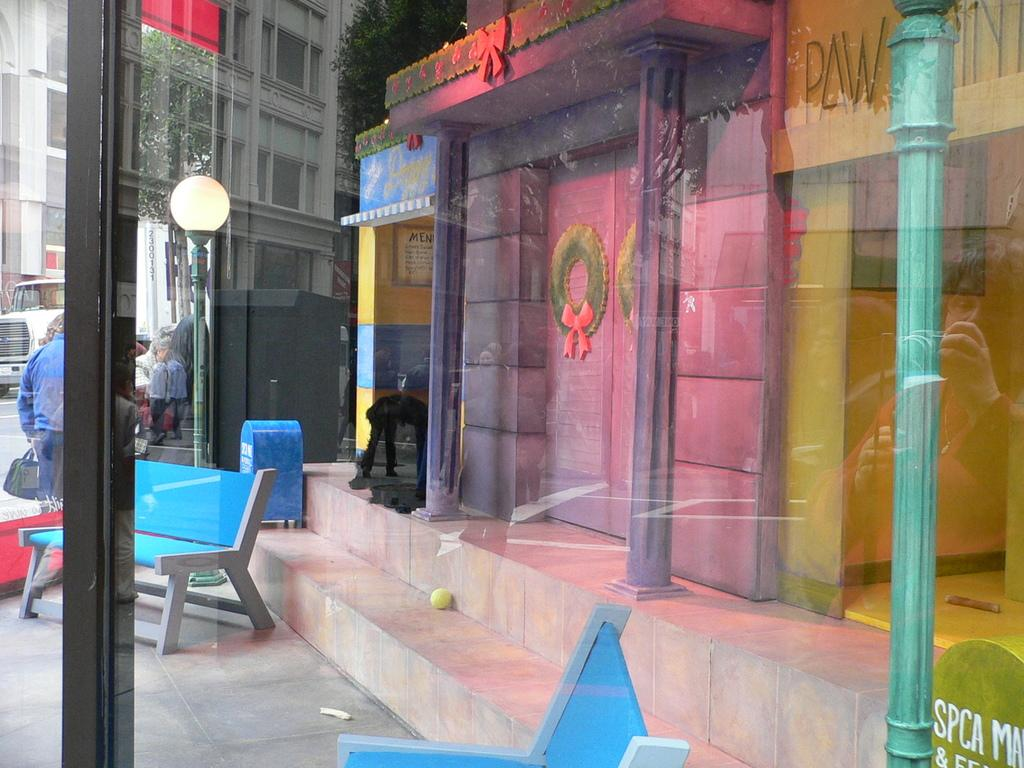What material is present in the image? There is glass in the image. What type of seating can be seen in the image? There are benches in the image. What structures are visible in the image? There are buildings in the image. What can be seen in the background of the image? There are people, trees, light, and a truck visible in the background of the image. What type of wood is used to construct the wall in the image? There is no wall present in the image, and therefore no wood can be observed. How does the brake function on the truck in the image? There is no mention of a brake or any vehicle operation in the image; it only shows a truck in the background. 